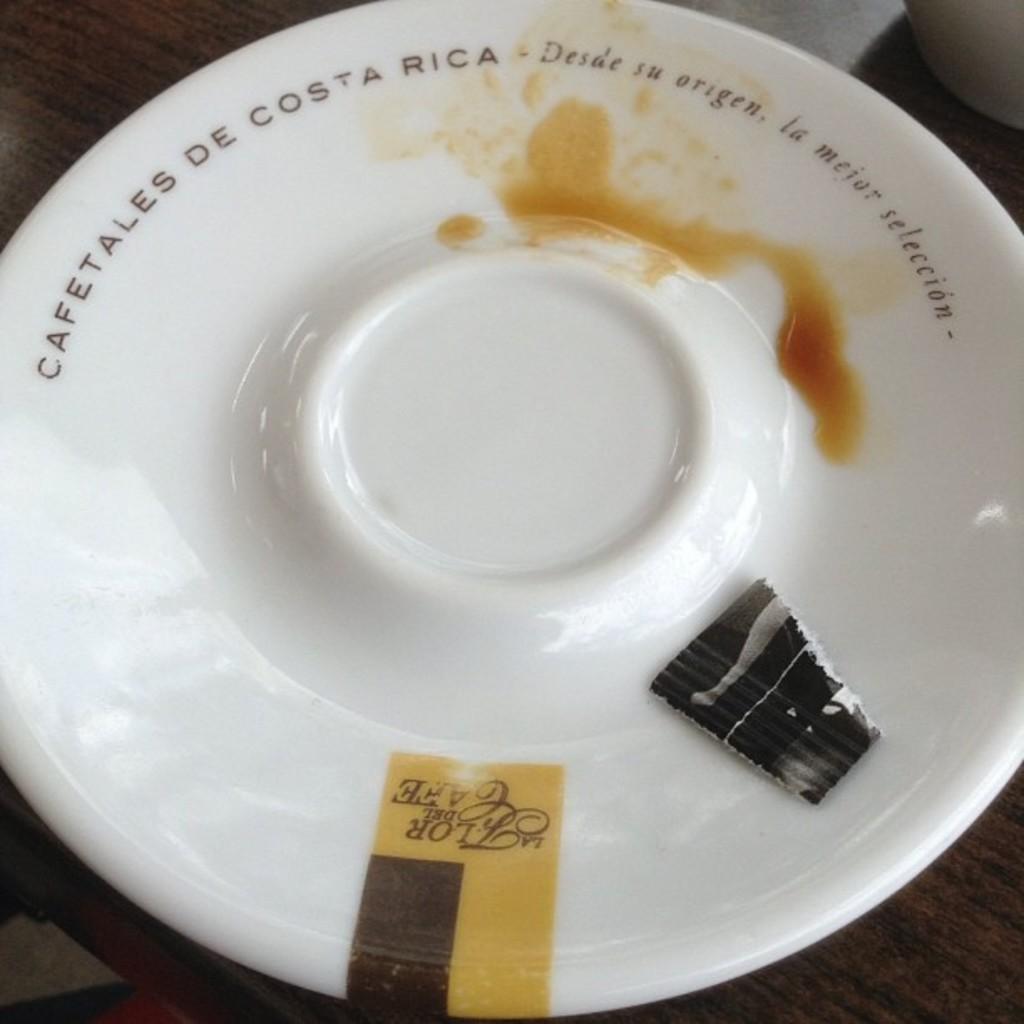In one or two sentences, can you explain what this image depicts? In this picture we can see a plate on a wooden surface and some objects. 